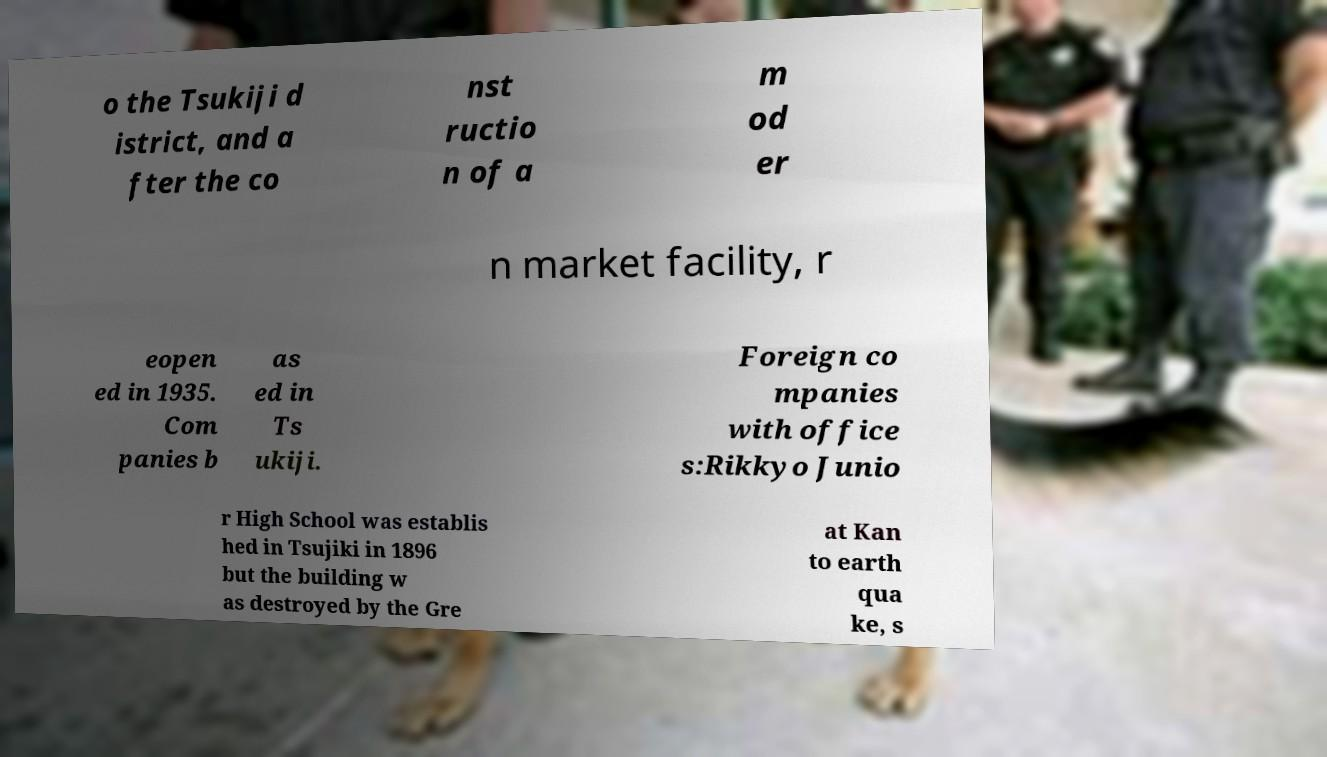Please read and relay the text visible in this image. What does it say? o the Tsukiji d istrict, and a fter the co nst ructio n of a m od er n market facility, r eopen ed in 1935. Com panies b as ed in Ts ukiji. Foreign co mpanies with office s:Rikkyo Junio r High School was establis hed in Tsujiki in 1896 but the building w as destroyed by the Gre at Kan to earth qua ke, s 